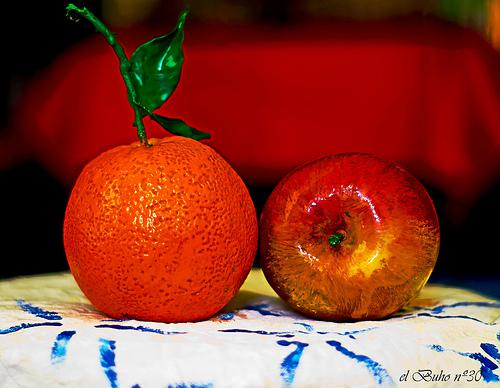Question: what fruit is on the right?
Choices:
A. Apple.
B. Banana.
C. Orange.
D. Pear.
Answer with the letter. Answer: A Question: where is the orange?
Choices:
A. In the bowl.
B. On the counter.
C. Next to the apple.
D. On the plate.
Answer with the letter. Answer: C Question: who is eating the apple?
Choices:
A. The girl.
B. The boy.
C. The old man.
D. No one.
Answer with the letter. Answer: D Question: why are they so shiny?
Choices:
A. Just been washed.
B. Reflecting the sun.
C. No particular reason.
D. Reflecting a flash.
Answer with the letter. Answer: D Question: how many apple are there?
Choices:
A. A dozen.
B. One.
C. Nine.
D. Three.
Answer with the letter. Answer: B 